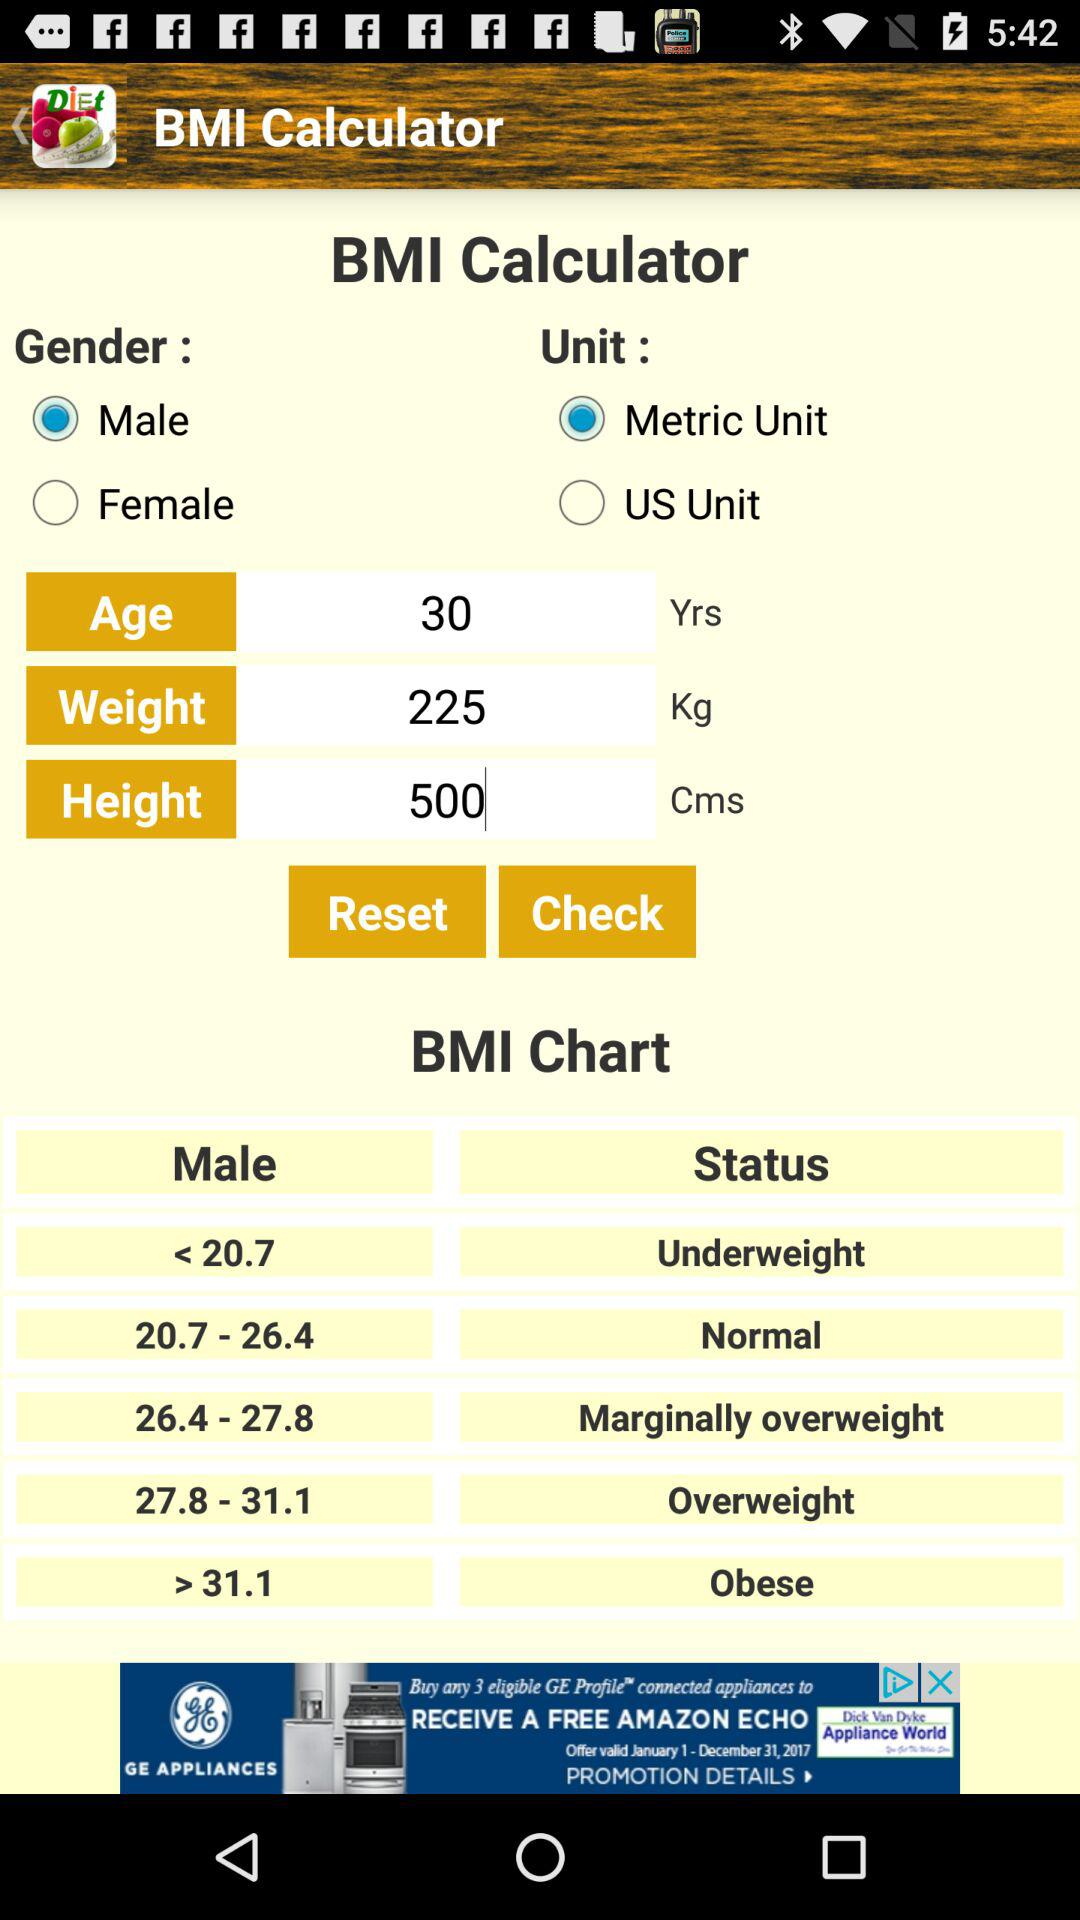How many options are there for the unit of measurement?
Answer the question using a single word or phrase. 2 